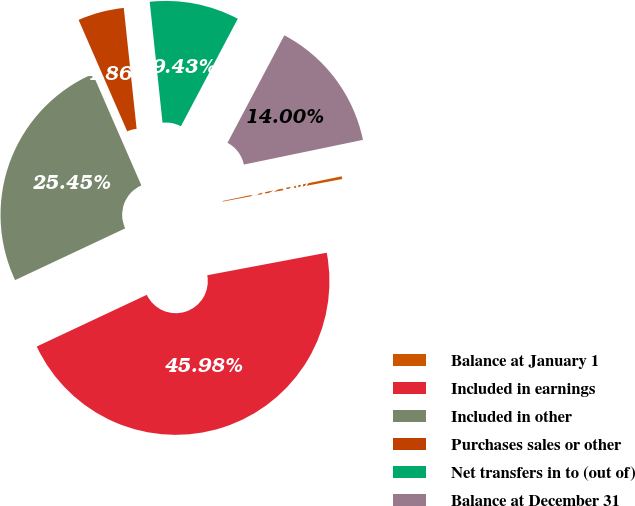<chart> <loc_0><loc_0><loc_500><loc_500><pie_chart><fcel>Balance at January 1<fcel>Included in earnings<fcel>Included in other<fcel>Purchases sales or other<fcel>Net transfers in to (out of)<fcel>Balance at December 31<nl><fcel>0.29%<fcel>45.98%<fcel>25.45%<fcel>4.86%<fcel>9.43%<fcel>14.0%<nl></chart> 